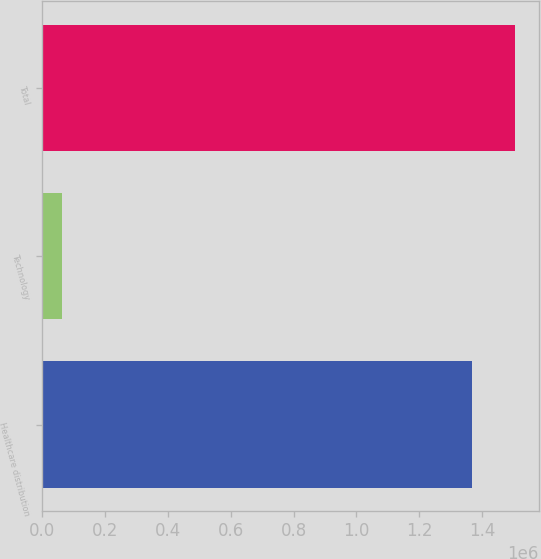Convert chart to OTSL. <chart><loc_0><loc_0><loc_500><loc_500><bar_chart><fcel>Healthcare distribution<fcel>Technology<fcel>Total<nl><fcel>1.36811e+06<fcel>63661<fcel>1.50492e+06<nl></chart> 